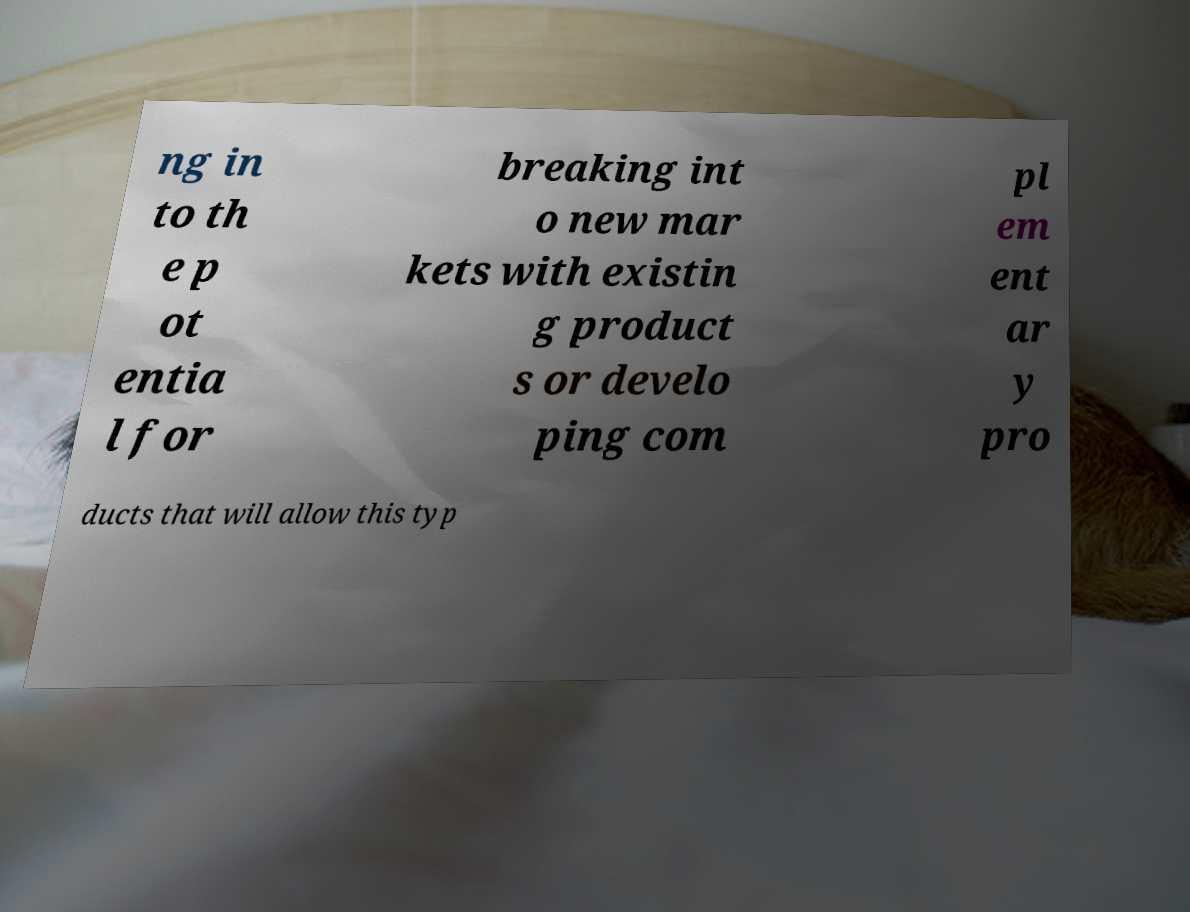There's text embedded in this image that I need extracted. Can you transcribe it verbatim? ng in to th e p ot entia l for breaking int o new mar kets with existin g product s or develo ping com pl em ent ar y pro ducts that will allow this typ 